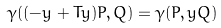<formula> <loc_0><loc_0><loc_500><loc_500>\gamma ( ( - y + T y ) P , Q ) = \gamma ( P , y Q )</formula> 